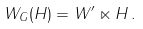Convert formula to latex. <formula><loc_0><loc_0><loc_500><loc_500>W _ { G } ( H ) = W ^ { \prime } \ltimes H \, .</formula> 